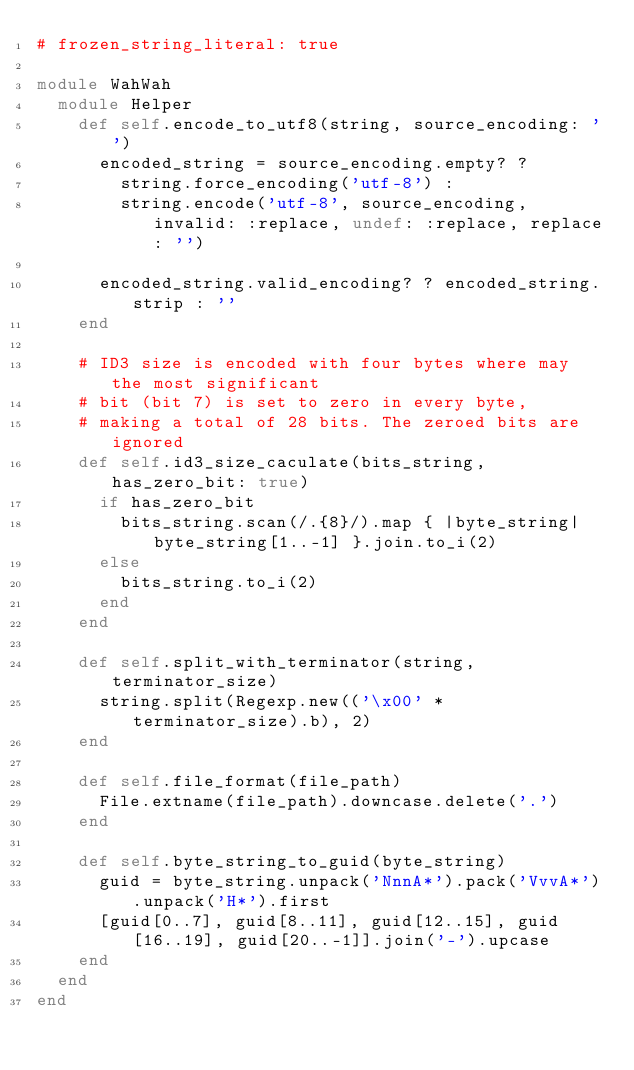Convert code to text. <code><loc_0><loc_0><loc_500><loc_500><_Ruby_># frozen_string_literal: true

module WahWah
  module Helper
    def self.encode_to_utf8(string, source_encoding: '')
      encoded_string = source_encoding.empty? ?
        string.force_encoding('utf-8') :
        string.encode('utf-8', source_encoding, invalid: :replace, undef: :replace, replace: '')

      encoded_string.valid_encoding? ? encoded_string.strip : ''
    end

    # ID3 size is encoded with four bytes where may the most significant
    # bit (bit 7) is set to zero in every byte,
    # making a total of 28 bits. The zeroed bits are ignored
    def self.id3_size_caculate(bits_string, has_zero_bit: true)
      if has_zero_bit
        bits_string.scan(/.{8}/).map { |byte_string| byte_string[1..-1] }.join.to_i(2)
      else
        bits_string.to_i(2)
      end
    end

    def self.split_with_terminator(string, terminator_size)
      string.split(Regexp.new(('\x00' * terminator_size).b), 2)
    end

    def self.file_format(file_path)
      File.extname(file_path).downcase.delete('.')
    end

    def self.byte_string_to_guid(byte_string)
      guid = byte_string.unpack('NnnA*').pack('VvvA*').unpack('H*').first
      [guid[0..7], guid[8..11], guid[12..15], guid[16..19], guid[20..-1]].join('-').upcase
    end
  end
end
</code> 